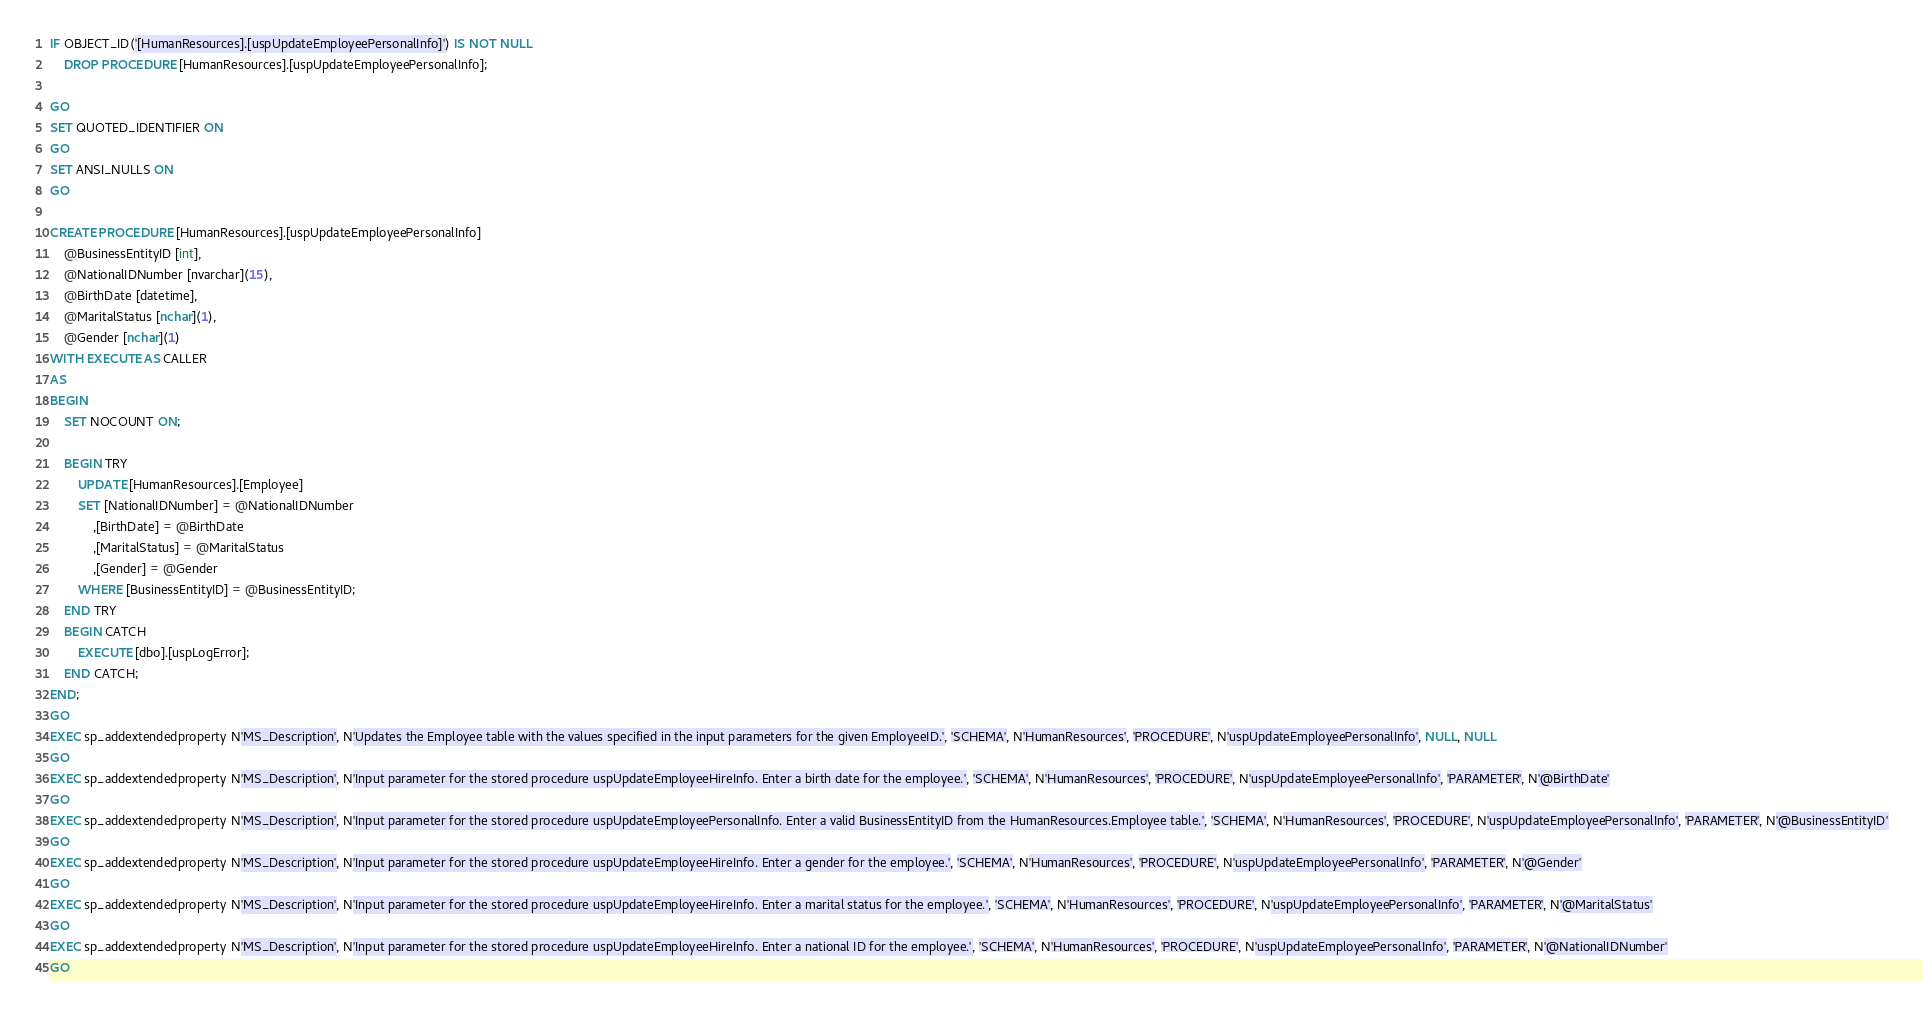Convert code to text. <code><loc_0><loc_0><loc_500><loc_500><_SQL_>IF OBJECT_ID('[HumanResources].[uspUpdateEmployeePersonalInfo]') IS NOT NULL
	DROP PROCEDURE [HumanResources].[uspUpdateEmployeePersonalInfo];

GO
SET QUOTED_IDENTIFIER ON
GO
SET ANSI_NULLS ON
GO

CREATE PROCEDURE [HumanResources].[uspUpdateEmployeePersonalInfo]
    @BusinessEntityID [int], 
    @NationalIDNumber [nvarchar](15), 
    @BirthDate [datetime], 
    @MaritalStatus [nchar](1), 
    @Gender [nchar](1)
WITH EXECUTE AS CALLER
AS
BEGIN
    SET NOCOUNT ON;

    BEGIN TRY
        UPDATE [HumanResources].[Employee] 
        SET [NationalIDNumber] = @NationalIDNumber 
            ,[BirthDate] = @BirthDate 
            ,[MaritalStatus] = @MaritalStatus 
            ,[Gender] = @Gender 
        WHERE [BusinessEntityID] = @BusinessEntityID;
    END TRY
    BEGIN CATCH
        EXECUTE [dbo].[uspLogError];
    END CATCH;
END;
GO
EXEC sp_addextendedproperty N'MS_Description', N'Updates the Employee table with the values specified in the input parameters for the given EmployeeID.', 'SCHEMA', N'HumanResources', 'PROCEDURE', N'uspUpdateEmployeePersonalInfo', NULL, NULL
GO
EXEC sp_addextendedproperty N'MS_Description', N'Input parameter for the stored procedure uspUpdateEmployeeHireInfo. Enter a birth date for the employee.', 'SCHEMA', N'HumanResources', 'PROCEDURE', N'uspUpdateEmployeePersonalInfo', 'PARAMETER', N'@BirthDate'
GO
EXEC sp_addextendedproperty N'MS_Description', N'Input parameter for the stored procedure uspUpdateEmployeePersonalInfo. Enter a valid BusinessEntityID from the HumanResources.Employee table.', 'SCHEMA', N'HumanResources', 'PROCEDURE', N'uspUpdateEmployeePersonalInfo', 'PARAMETER', N'@BusinessEntityID'
GO
EXEC sp_addextendedproperty N'MS_Description', N'Input parameter for the stored procedure uspUpdateEmployeeHireInfo. Enter a gender for the employee.', 'SCHEMA', N'HumanResources', 'PROCEDURE', N'uspUpdateEmployeePersonalInfo', 'PARAMETER', N'@Gender'
GO
EXEC sp_addextendedproperty N'MS_Description', N'Input parameter for the stored procedure uspUpdateEmployeeHireInfo. Enter a marital status for the employee.', 'SCHEMA', N'HumanResources', 'PROCEDURE', N'uspUpdateEmployeePersonalInfo', 'PARAMETER', N'@MaritalStatus'
GO
EXEC sp_addextendedproperty N'MS_Description', N'Input parameter for the stored procedure uspUpdateEmployeeHireInfo. Enter a national ID for the employee.', 'SCHEMA', N'HumanResources', 'PROCEDURE', N'uspUpdateEmployeePersonalInfo', 'PARAMETER', N'@NationalIDNumber'
GO
</code> 